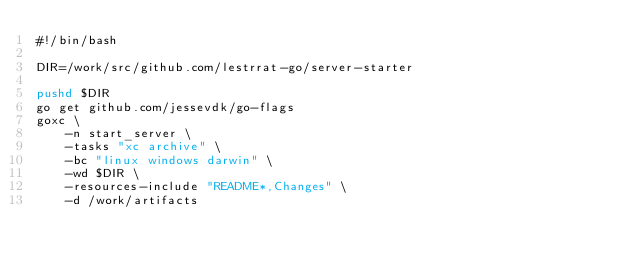Convert code to text. <code><loc_0><loc_0><loc_500><loc_500><_Bash_>#!/bin/bash

DIR=/work/src/github.com/lestrrat-go/server-starter

pushd $DIR
go get github.com/jessevdk/go-flags
goxc \
    -n start_server \
    -tasks "xc archive" \
    -bc "linux windows darwin" \
    -wd $DIR \
    -resources-include "README*,Changes" \
    -d /work/artifacts</code> 